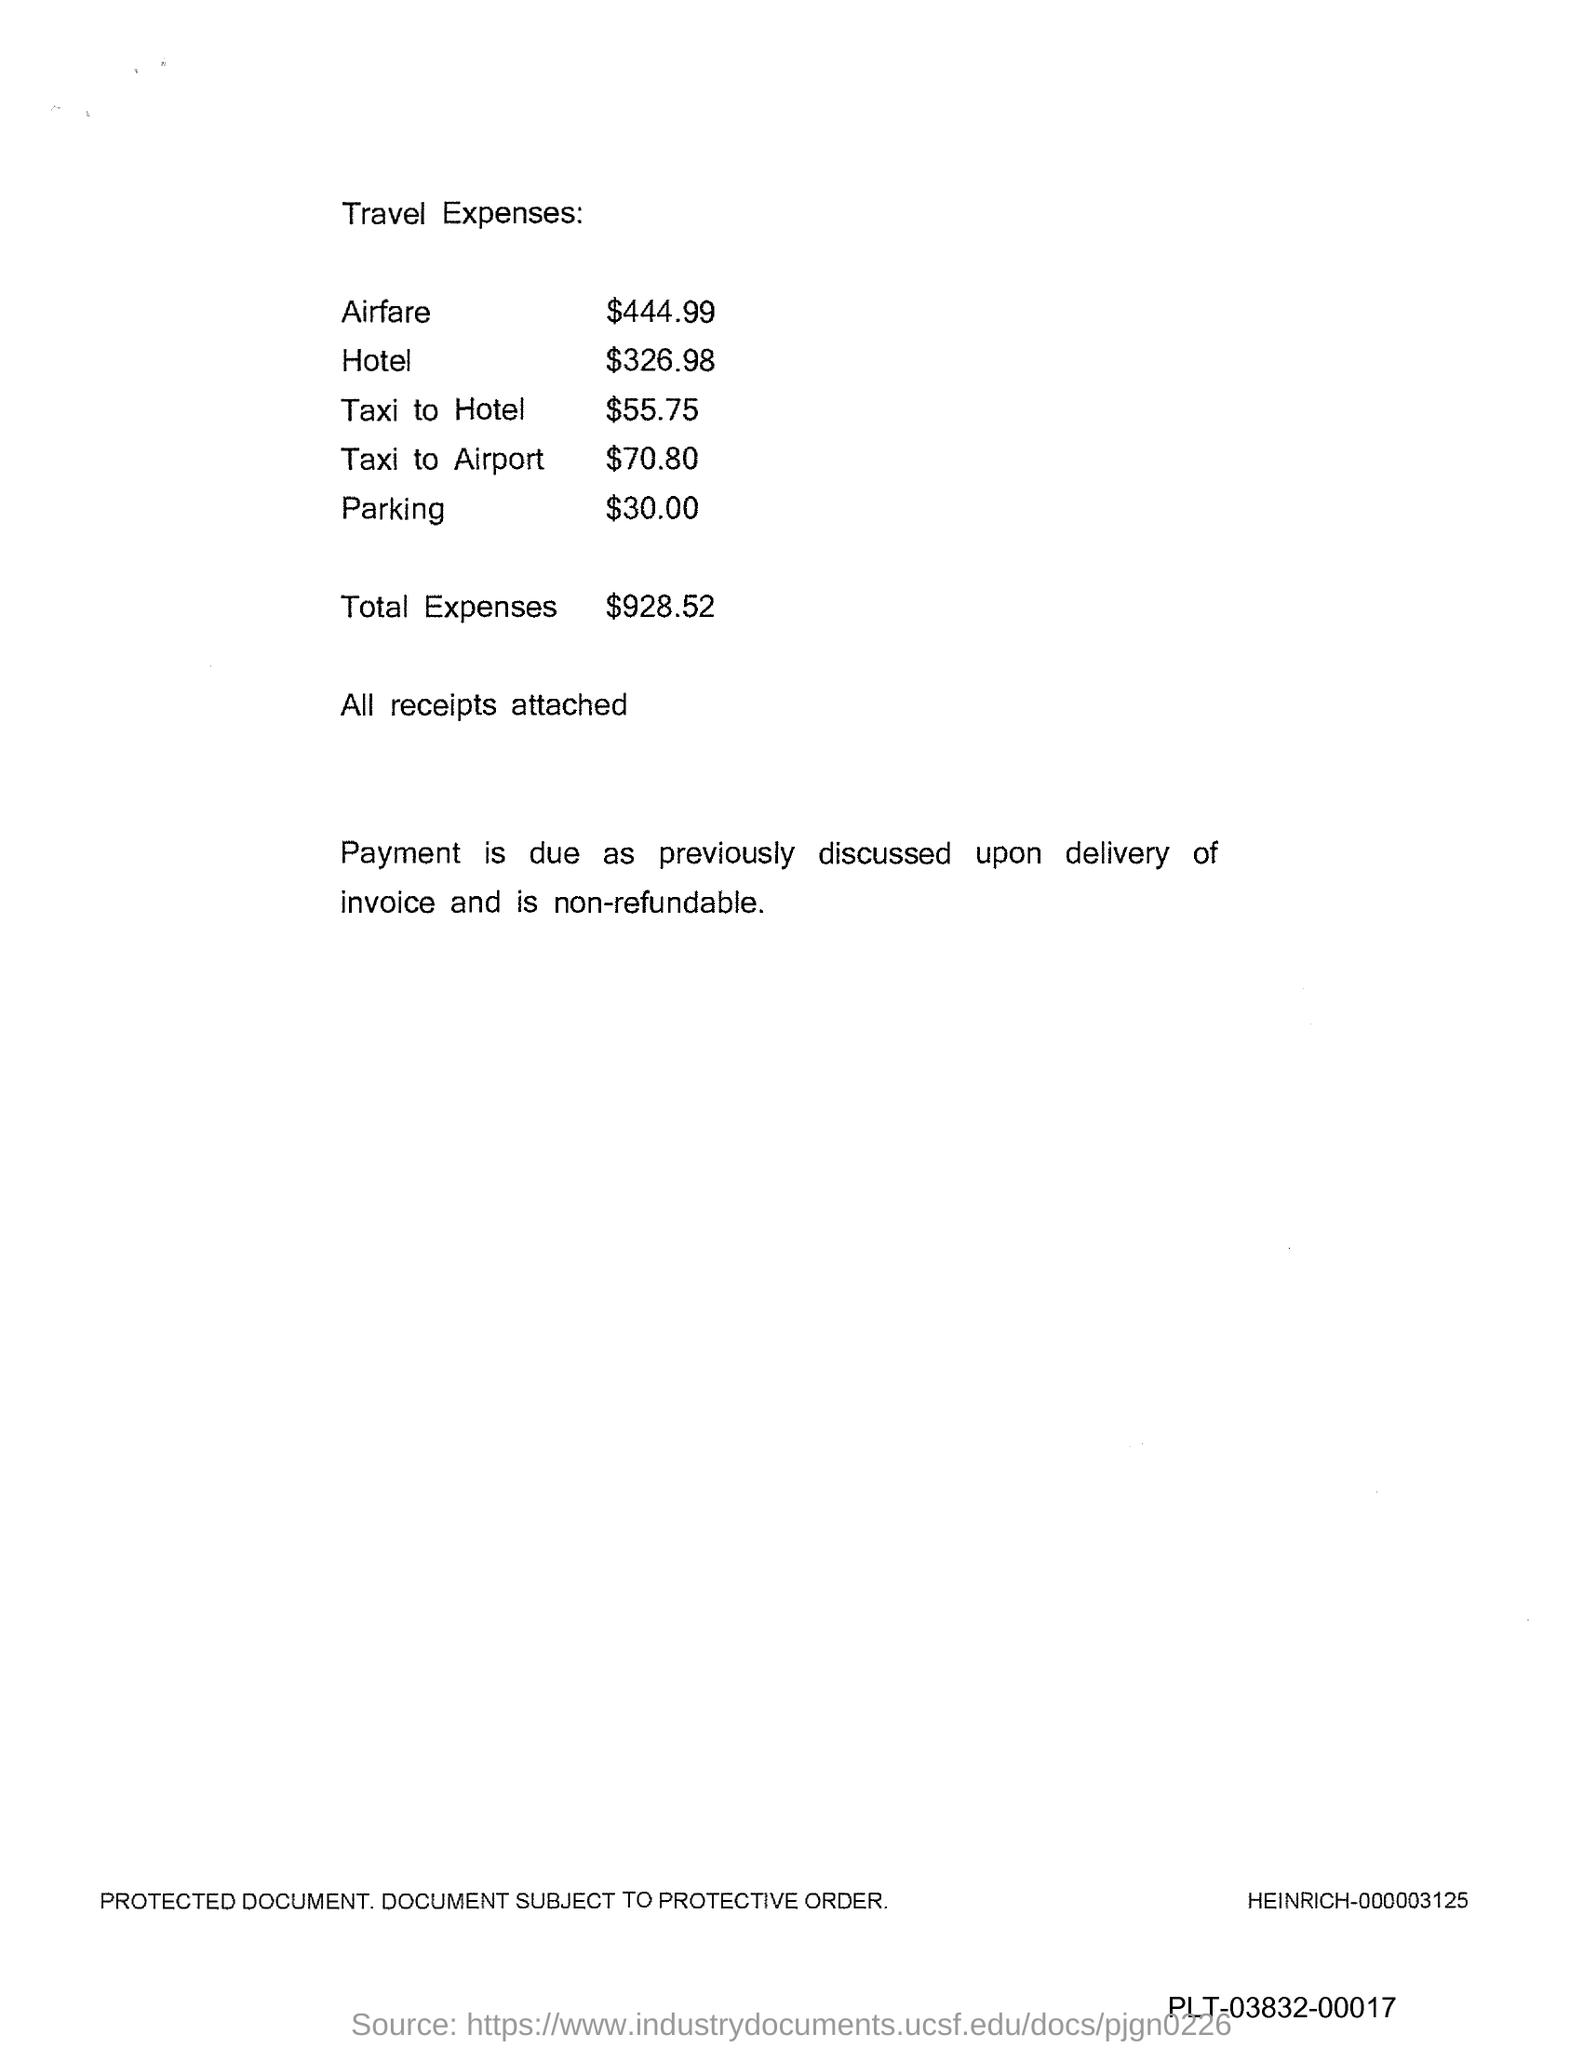List a handful of essential elements in this visual. The parking expense is $30. The hotel expense is 326.98. The total expenses mentioned in the document are $928.52. 